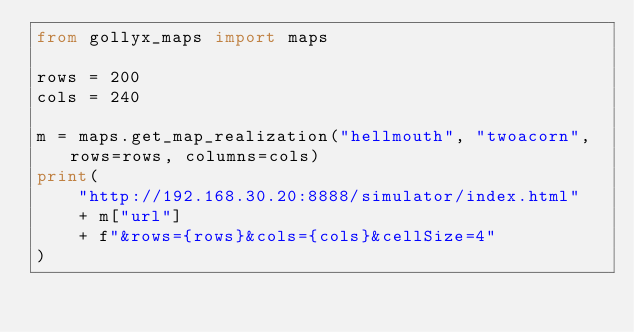<code> <loc_0><loc_0><loc_500><loc_500><_Python_>from gollyx_maps import maps

rows = 200
cols = 240

m = maps.get_map_realization("hellmouth", "twoacorn", rows=rows, columns=cols)
print(
    "http://192.168.30.20:8888/simulator/index.html"
    + m["url"]
    + f"&rows={rows}&cols={cols}&cellSize=4"
)
</code> 